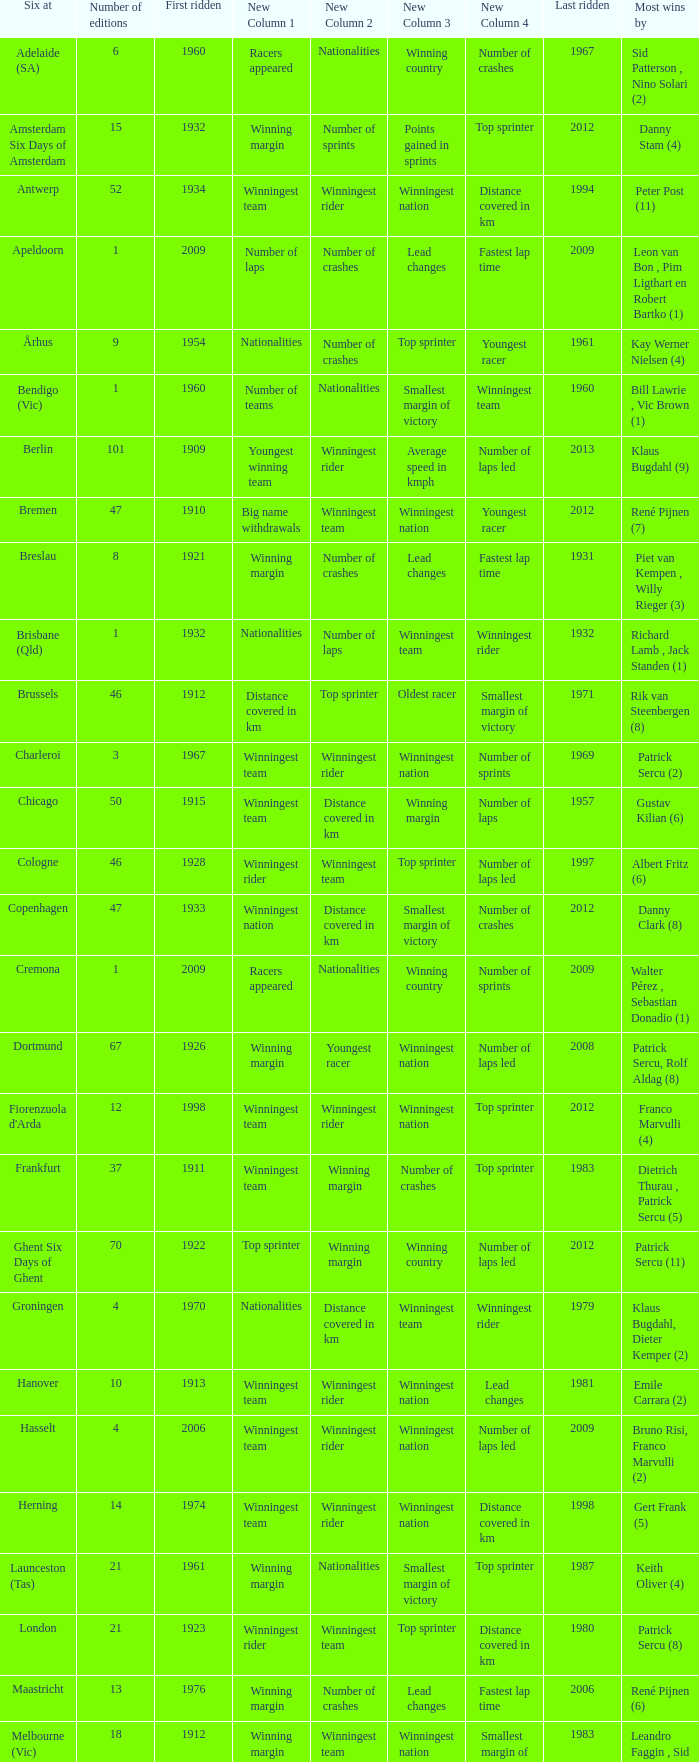How many editions have a most wins value of Franco Marvulli (4)? 1.0. 